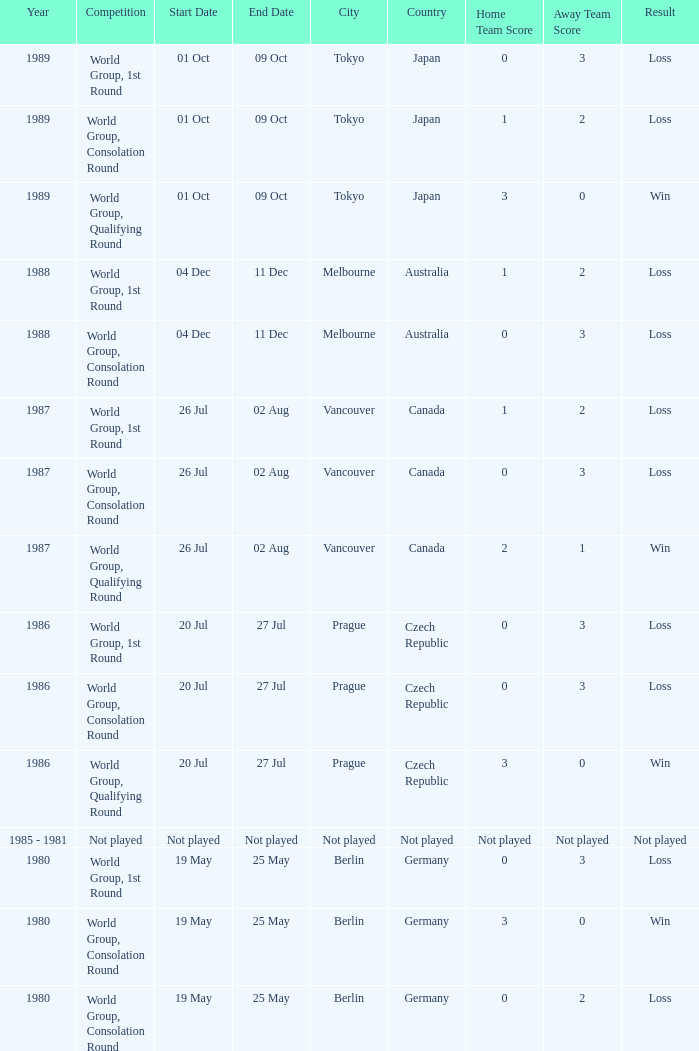What is the year when the date is not played? 1985 - 1981. 